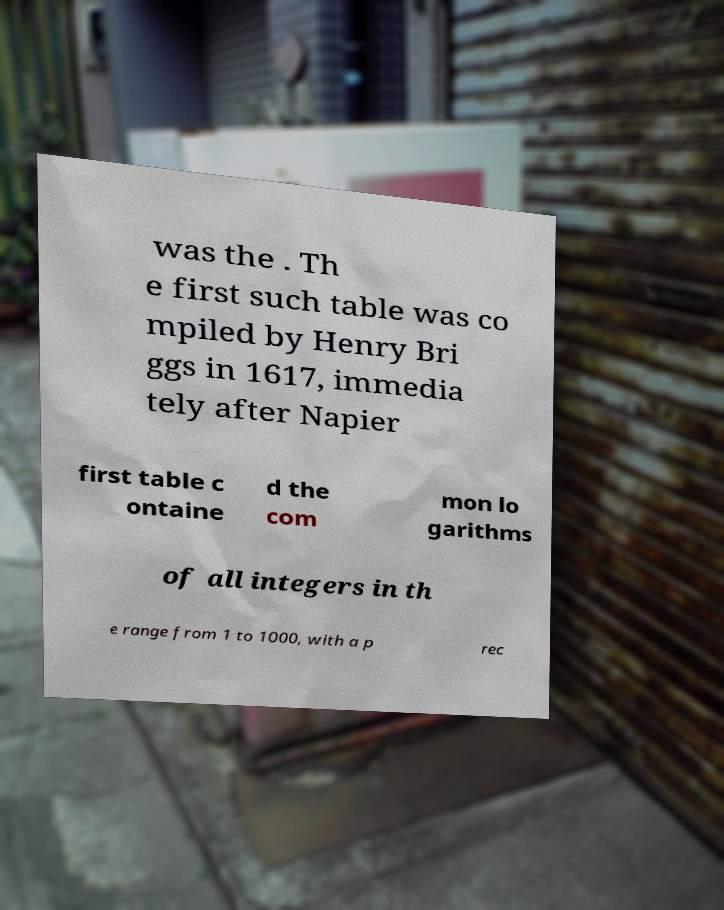There's text embedded in this image that I need extracted. Can you transcribe it verbatim? was the . Th e first such table was co mpiled by Henry Bri ggs in 1617, immedia tely after Napier first table c ontaine d the com mon lo garithms of all integers in th e range from 1 to 1000, with a p rec 